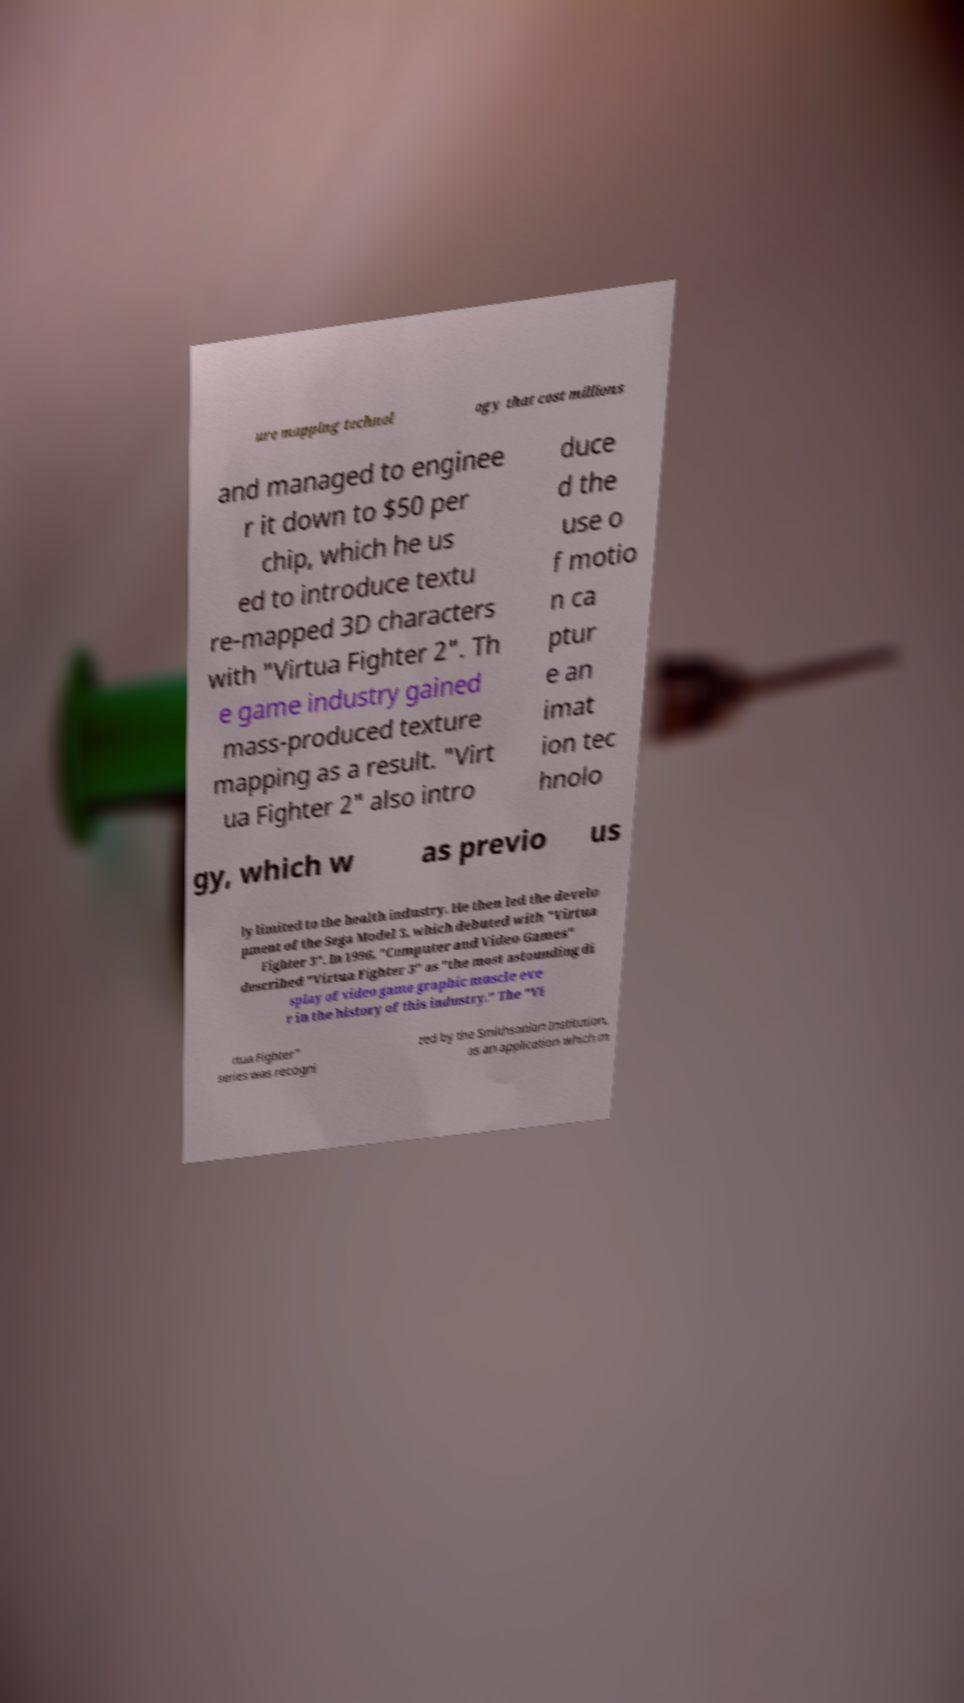I need the written content from this picture converted into text. Can you do that? ure mapping technol ogy that cost millions and managed to enginee r it down to $50 per chip, which he us ed to introduce textu re-mapped 3D characters with "Virtua Fighter 2". Th e game industry gained mass-produced texture mapping as a result. "Virt ua Fighter 2" also intro duce d the use o f motio n ca ptur e an imat ion tec hnolo gy, which w as previo us ly limited to the health industry. He then led the develo pment of the Sega Model 3, which debuted with "Virtua Fighter 3". In 1996, "Computer and Video Games" described "Virtua Fighter 3" as "the most astounding di splay of video game graphic muscle eve r in the history of this industry." The "Vi rtua Fighter" series was recogni zed by the Smithsonian Institution, as an application which m 